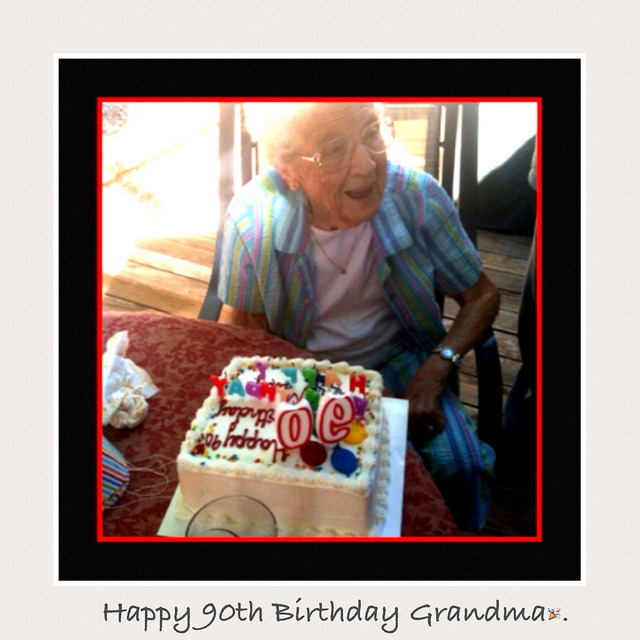Please transcribe the text in this image. Happy goth Birthday Grandma oe 